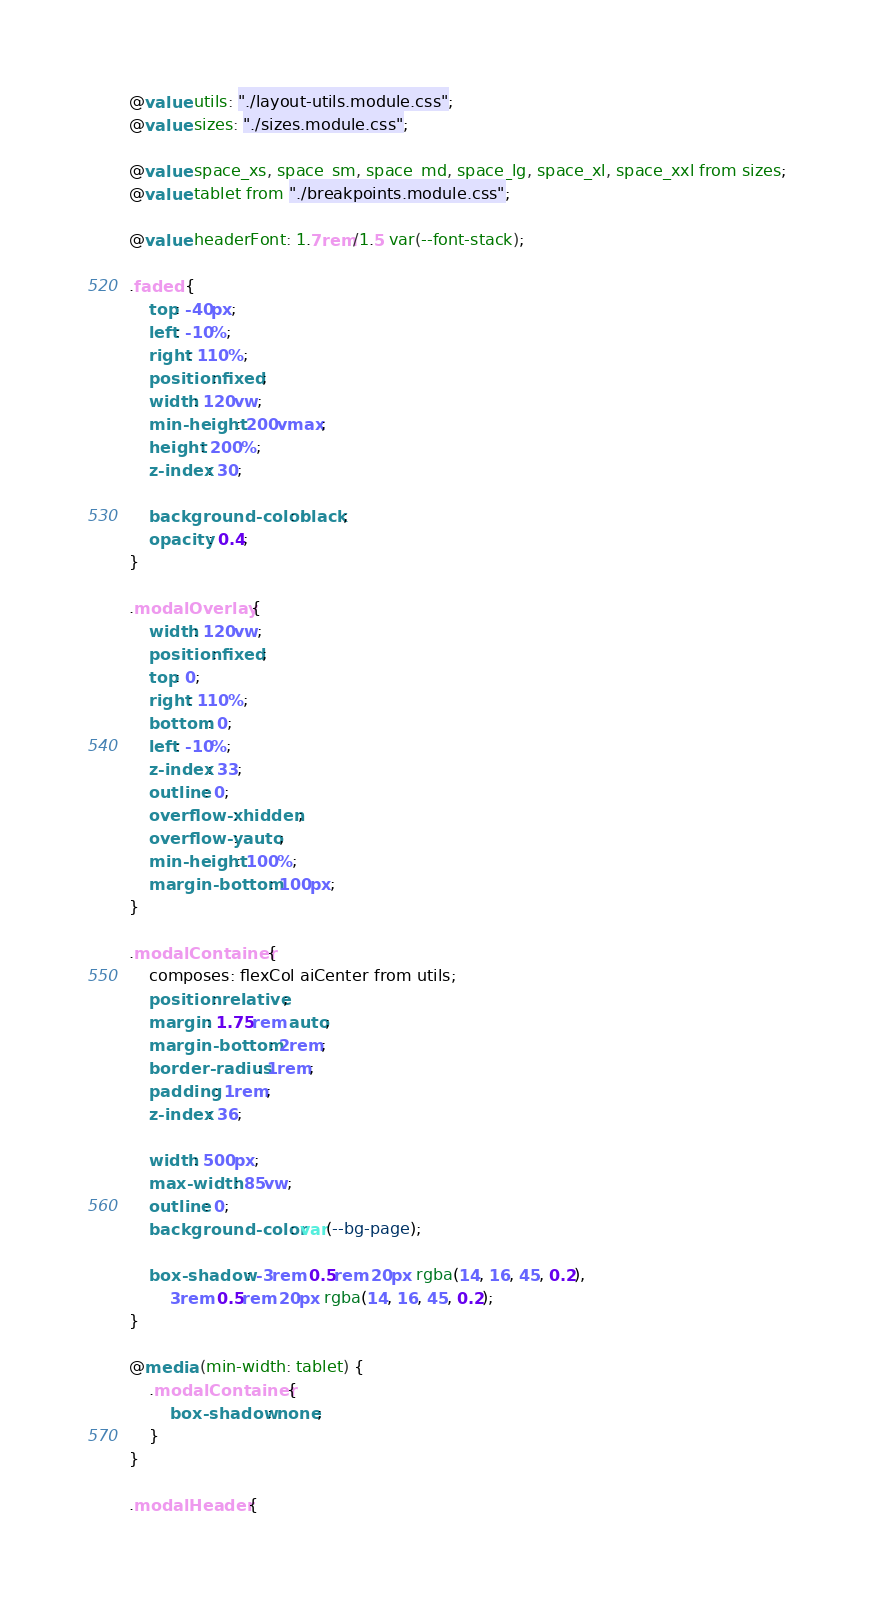<code> <loc_0><loc_0><loc_500><loc_500><_CSS_>@value utils: "./layout-utils.module.css";
@value sizes: "./sizes.module.css";

@value space_xs, space_sm, space_md, space_lg, space_xl, space_xxl from sizes;
@value tablet from "./breakpoints.module.css";

@value headerFont: 1.7rem/1.5 var(--font-stack);

.faded {
    top: -40px;
    left: -10%;
    right: 110%;
    position: fixed;
    width: 120vw;
    min-height: 200vmax;
    height: 200%;
    z-index: 30;

    background-color: black;
    opacity: 0.4;
}

.modalOverlay {
    width: 120vw;
    position: fixed;
    top: 0;
    right: 110%;
    bottom: 0;
    left: -10%;
    z-index: 33;
    outline: 0;
    overflow-x: hidden;
    overflow-y: auto;
    min-height: 100%;
    margin-bottom: 100px;
}

.modalContainer {
    composes: flexCol aiCenter from utils;
    position: relative;
    margin: 1.75rem auto;
    margin-bottom: 2rem;
    border-radius: 1rem;
    padding: 1rem;
    z-index: 36;

    width: 500px;
    max-width: 85vw;
    outline: 0;
    background-color: var(--bg-page);

    box-shadow: -3rem 0.5rem 20px rgba(14, 16, 45, 0.2),
        3rem 0.5rem 20px rgba(14, 16, 45, 0.2);
}

@media (min-width: tablet) {
    .modalContainer {
        box-shadow: none;
    }
}

.modalHeader {</code> 